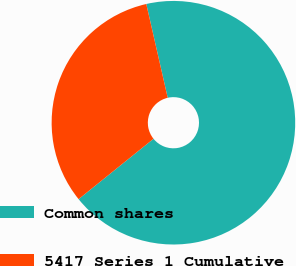Convert chart. <chart><loc_0><loc_0><loc_500><loc_500><pie_chart><fcel>Common shares<fcel>5417 Series 1 Cumulative<nl><fcel>67.78%<fcel>32.22%<nl></chart> 